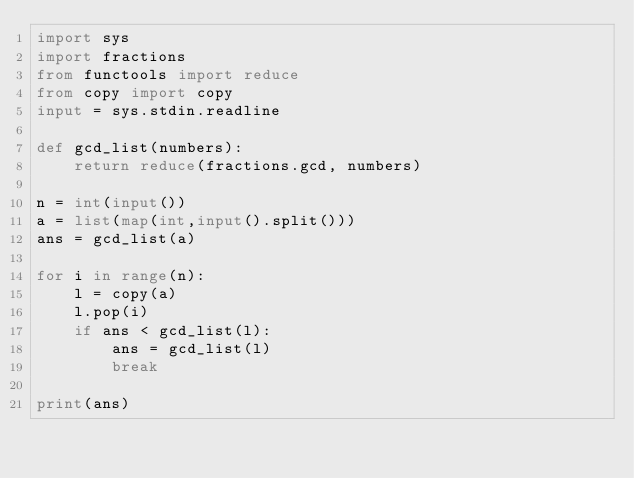Convert code to text. <code><loc_0><loc_0><loc_500><loc_500><_Python_>import sys
import fractions
from functools import reduce
from copy import copy
input = sys.stdin.readline

def gcd_list(numbers):
    return reduce(fractions.gcd, numbers)

n = int(input())
a = list(map(int,input().split()))
ans = gcd_list(a)

for i in range(n):
    l = copy(a)
    l.pop(i)
    if ans < gcd_list(l):
        ans = gcd_list(l)
        break

print(ans)</code> 